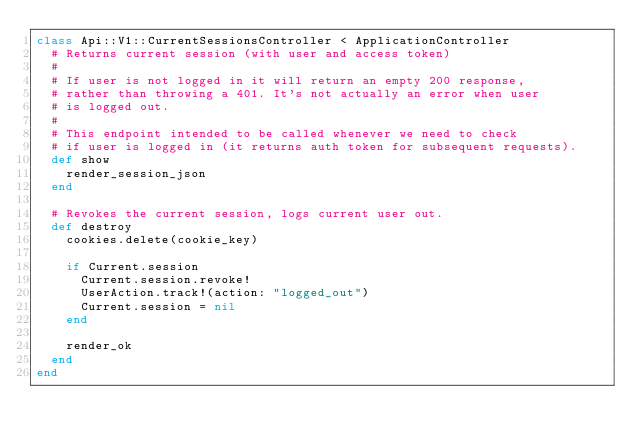Convert code to text. <code><loc_0><loc_0><loc_500><loc_500><_Ruby_>class Api::V1::CurrentSessionsController < ApplicationController
  # Returns current session (with user and access token)
  #
  # If user is not logged in it will return an empty 200 response,
  # rather than throwing a 401. It's not actually an error when user
  # is logged out.
  #
  # This endpoint intended to be called whenever we need to check
  # if user is logged in (it returns auth token for subsequent requests).
  def show
    render_session_json
  end

  # Revokes the current session, logs current user out.
  def destroy
    cookies.delete(cookie_key)

    if Current.session
      Current.session.revoke!
      UserAction.track!(action: "logged_out")
      Current.session = nil
    end

    render_ok
  end
end
</code> 